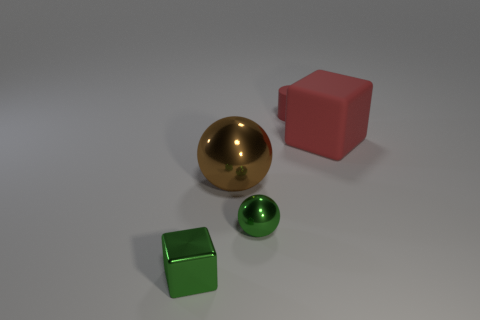Subtract all green spheres. How many spheres are left? 1 Add 3 small green metal things. How many objects exist? 8 Subtract all cylinders. How many objects are left? 4 Subtract 1 cubes. How many cubes are left? 1 Subtract all large yellow rubber cubes. Subtract all metal cubes. How many objects are left? 4 Add 5 red objects. How many red objects are left? 7 Add 1 yellow objects. How many yellow objects exist? 1 Subtract 0 cyan balls. How many objects are left? 5 Subtract all cyan spheres. Subtract all green cylinders. How many spheres are left? 2 Subtract all purple cubes. How many green spheres are left? 1 